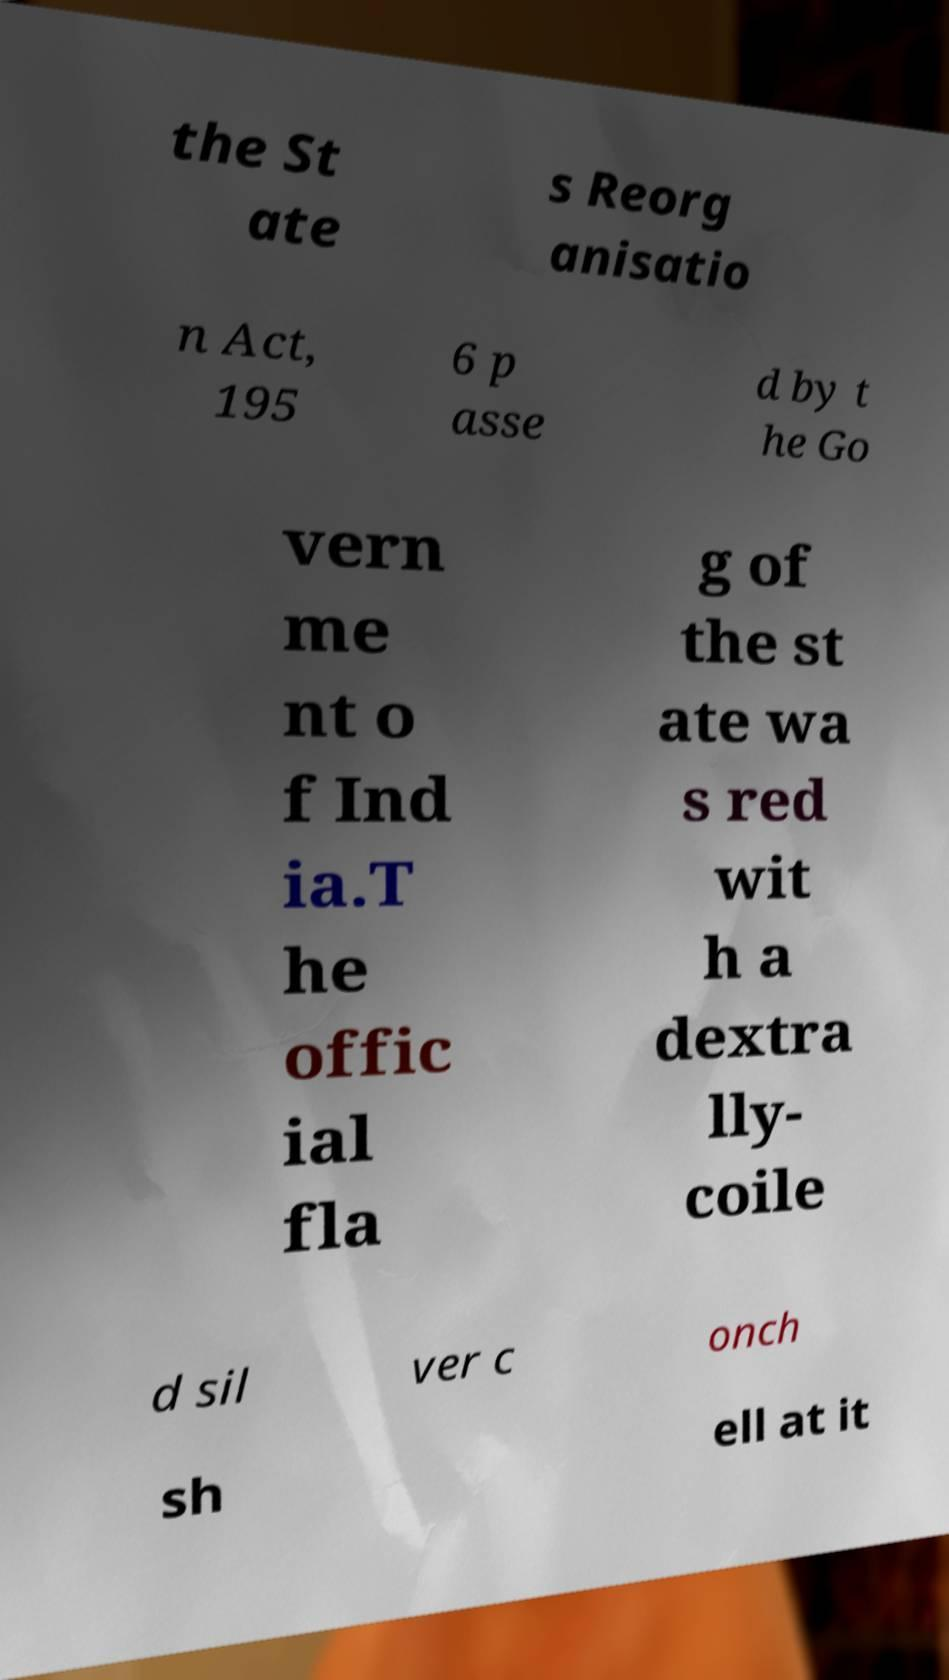Can you accurately transcribe the text from the provided image for me? the St ate s Reorg anisatio n Act, 195 6 p asse d by t he Go vern me nt o f Ind ia.T he offic ial fla g of the st ate wa s red wit h a dextra lly- coile d sil ver c onch sh ell at it 